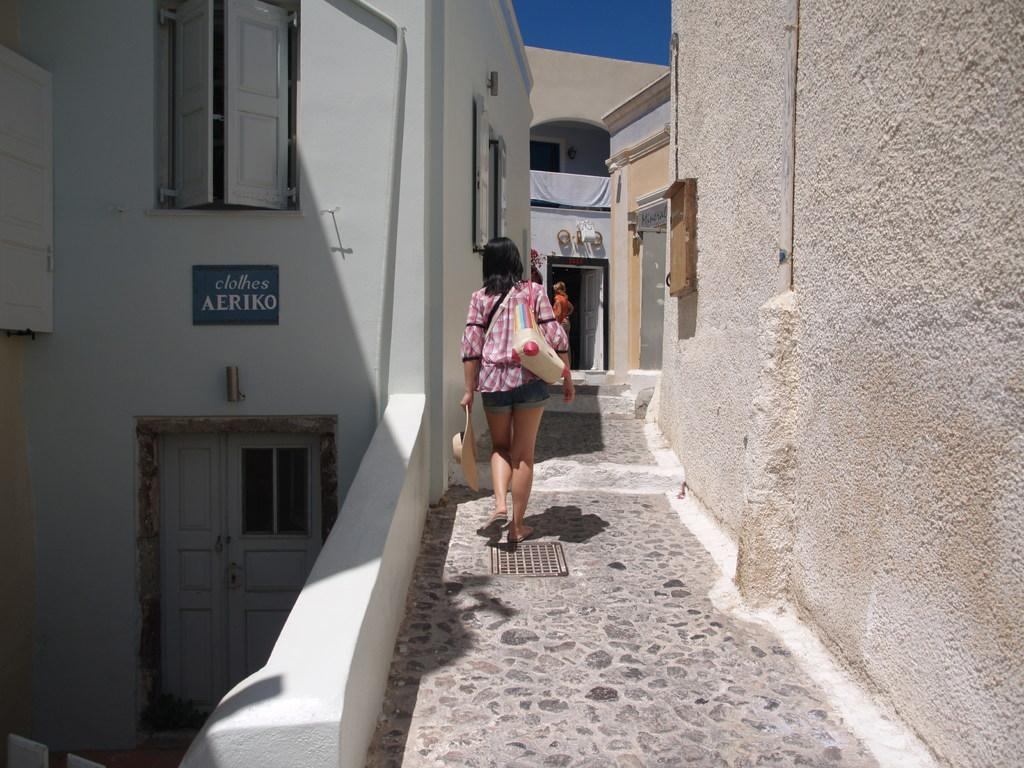Who is the main subject in the image? There is a woman in the image. What is the woman doing in the image? The woman is walking. What items is the woman holding in the image? The woman is holding a hat and a bag. Who or what is in front of the woman in the image? There is a person in front of the woman. What can be seen in the background of the image? There are buildings in front of the woman, and the sky is visible at the top of the image. How does the woman expand her knowledge while walking in the image? There is no indication in the image that the woman is expanding her knowledge or engaging in any specific activity while walking. 